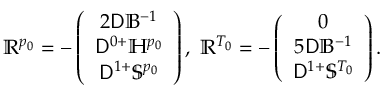<formula> <loc_0><loc_0><loc_500><loc_500>\mathbb { R } ^ { p _ { 0 } } = - \left ( \begin{array} { c } { 2 D \mathbb { B } ^ { - 1 } } \\ { D ^ { 0 + } \mathbb { H } ^ { p _ { 0 } } } \\ { D ^ { 1 + } \mathbb { S } ^ { p _ { 0 } } } \end{array} \right ) , \, \mathbb { R } ^ { T _ { 0 } } = - \left ( \begin{array} { c } { 0 } \\ { 5 D \mathbb { B } ^ { - 1 } } \\ { D ^ { 1 + } \mathbb { S } ^ { T _ { 0 } } } \end{array} \right ) .</formula> 